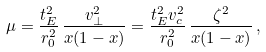Convert formula to latex. <formula><loc_0><loc_0><loc_500><loc_500>\mu = \frac { t _ { E } ^ { 2 } } { r _ { 0 } ^ { 2 } } \, \frac { v _ { \perp } ^ { 2 } } { x ( 1 - x ) } = \frac { t _ { E } ^ { 2 } v _ { c } ^ { 2 } } { r _ { 0 } ^ { 2 } } \, \frac { \zeta ^ { 2 } } { x ( 1 - x ) } \, ,</formula> 